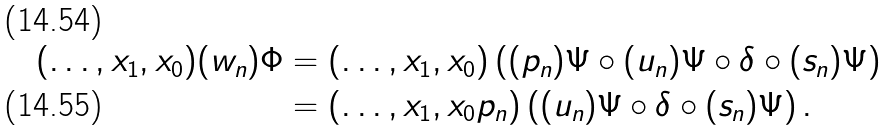Convert formula to latex. <formula><loc_0><loc_0><loc_500><loc_500>( \dots , x _ { 1 } , x _ { 0 } ) ( w _ { n } ) \Phi & = ( \dots , x _ { 1 } , x _ { 0 } ) \left ( ( p _ { n } ) \Psi \circ ( u _ { n } ) \Psi \circ \delta \circ ( s _ { n } ) \Psi \right ) \\ & = ( \dots , x _ { 1 } , x _ { 0 } p _ { n } ) \left ( ( u _ { n } ) \Psi \circ \delta \circ ( s _ { n } ) \Psi \right ) .</formula> 